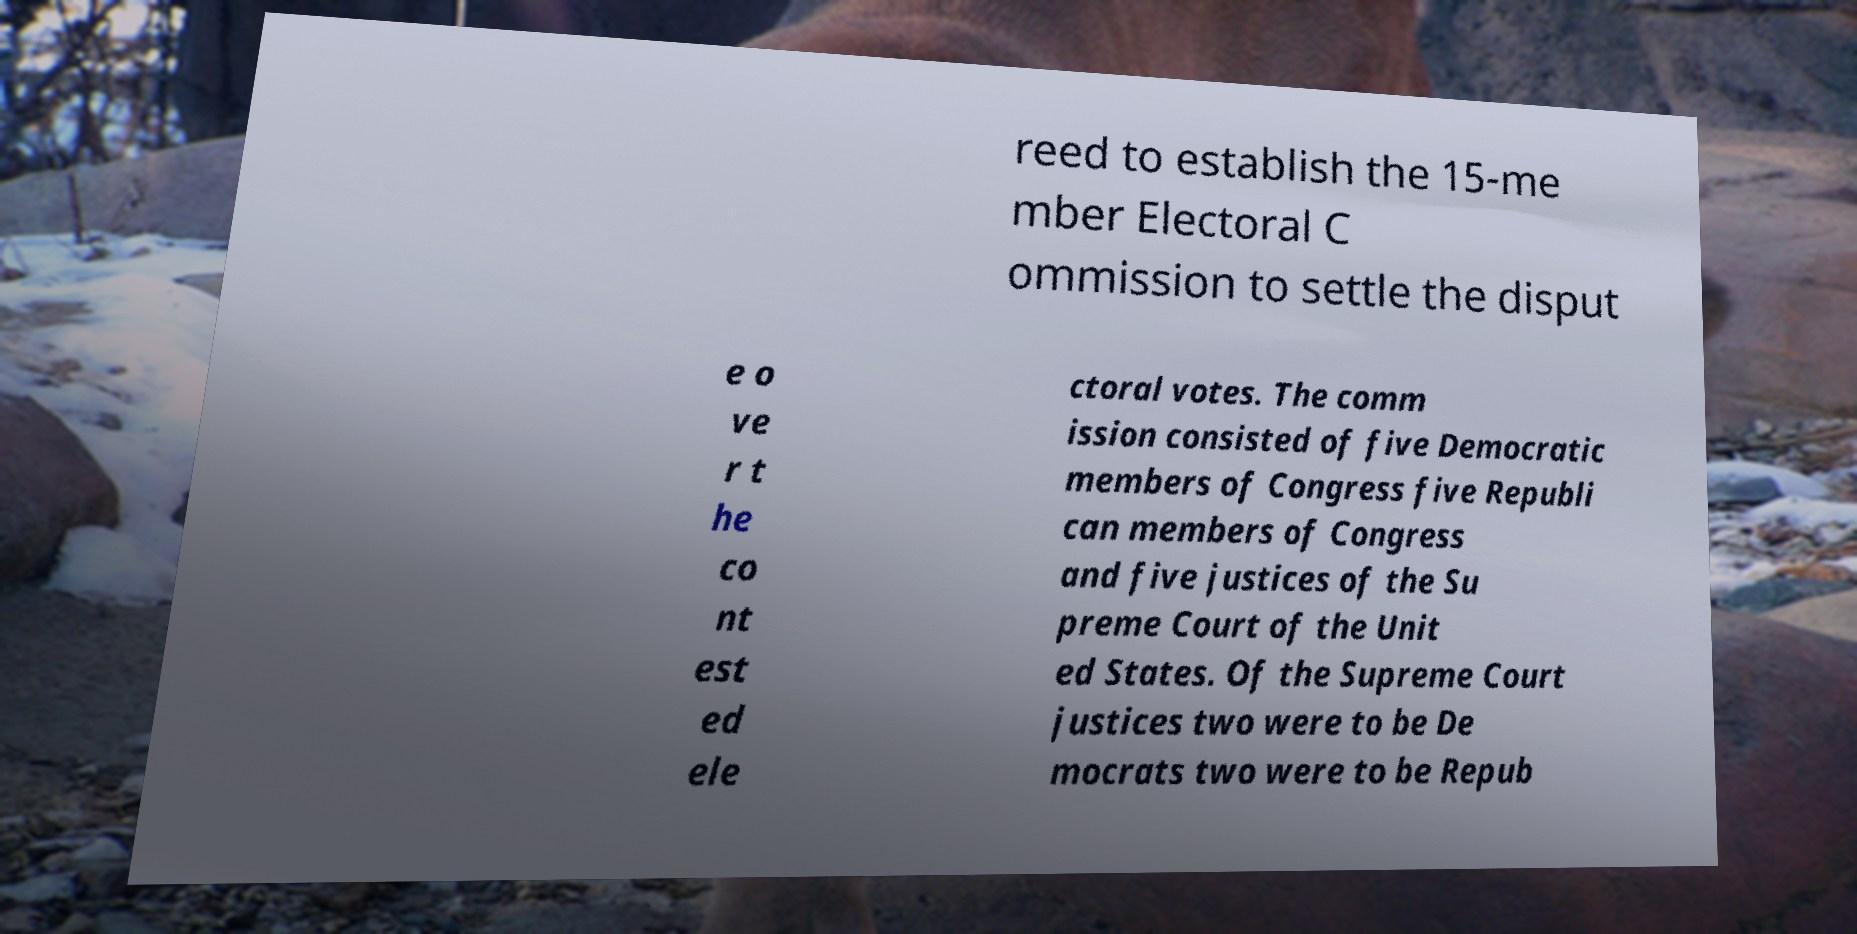I need the written content from this picture converted into text. Can you do that? reed to establish the 15-me mber Electoral C ommission to settle the disput e o ve r t he co nt est ed ele ctoral votes. The comm ission consisted of five Democratic members of Congress five Republi can members of Congress and five justices of the Su preme Court of the Unit ed States. Of the Supreme Court justices two were to be De mocrats two were to be Repub 